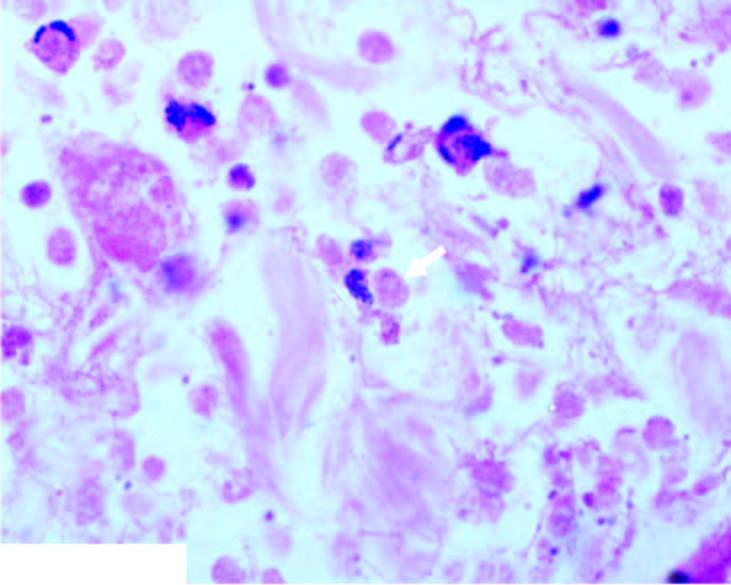does section from margin of amoebic ulcer show necrotic debris, acute inflammatory infiltrate and a few trophozoites of entamoeba histolytica?
Answer the question using a single word or phrase. Yes 